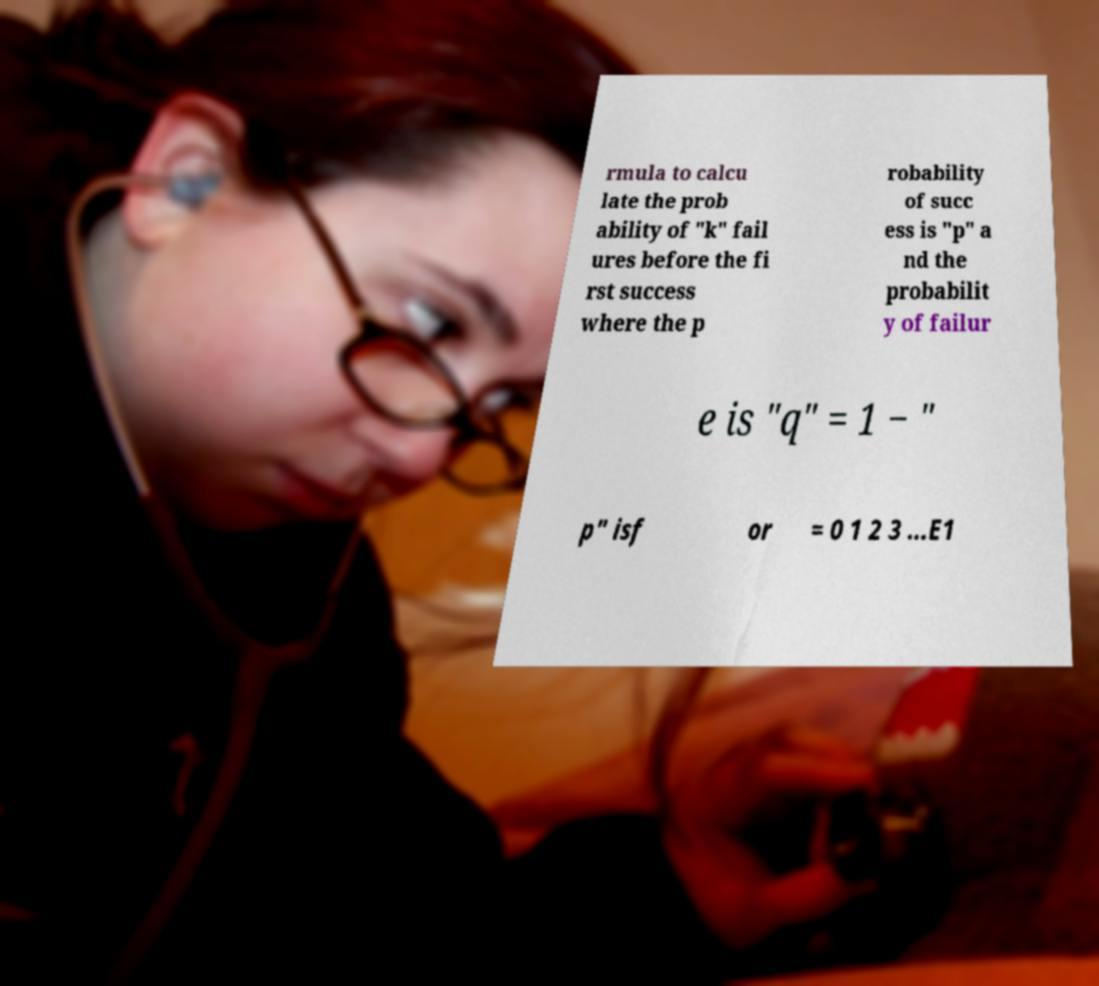Could you assist in decoding the text presented in this image and type it out clearly? rmula to calcu late the prob ability of "k" fail ures before the fi rst success where the p robability of succ ess is "p" a nd the probabilit y of failur e is "q" = 1 − " p" isf or = 0 1 2 3 ...E1 